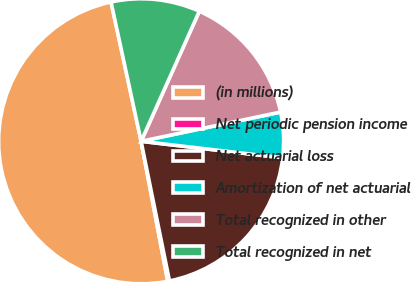Convert chart to OTSL. <chart><loc_0><loc_0><loc_500><loc_500><pie_chart><fcel>(in millions)<fcel>Net periodic pension income<fcel>Net actuarial loss<fcel>Amortization of net actuarial<fcel>Total recognized in other<fcel>Total recognized in net<nl><fcel>49.61%<fcel>0.2%<fcel>19.96%<fcel>5.14%<fcel>15.02%<fcel>10.08%<nl></chart> 